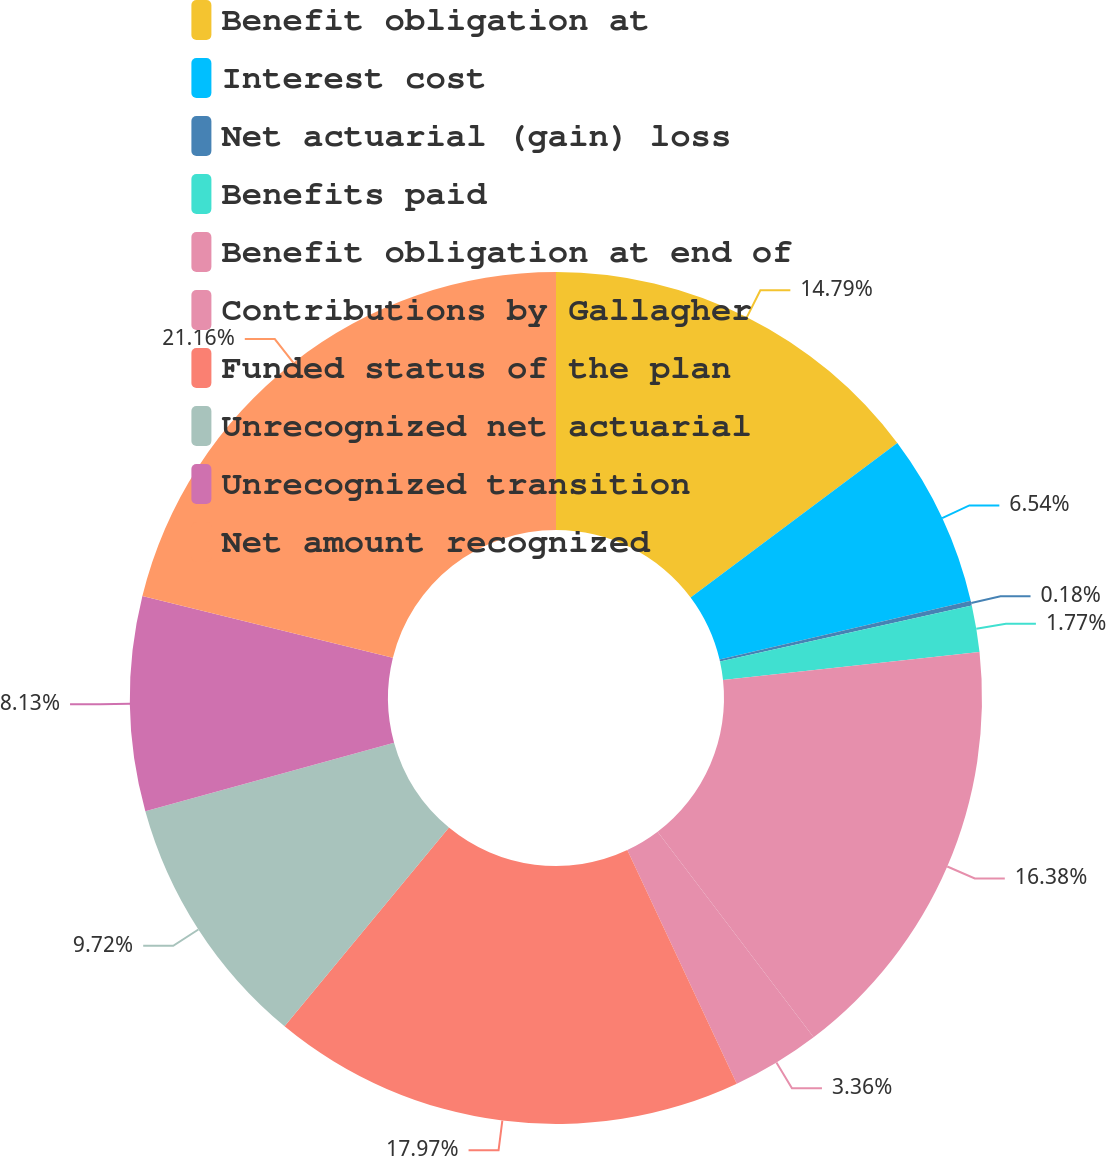Convert chart. <chart><loc_0><loc_0><loc_500><loc_500><pie_chart><fcel>Benefit obligation at<fcel>Interest cost<fcel>Net actuarial (gain) loss<fcel>Benefits paid<fcel>Benefit obligation at end of<fcel>Contributions by Gallagher<fcel>Funded status of the plan<fcel>Unrecognized net actuarial<fcel>Unrecognized transition<fcel>Net amount recognized<nl><fcel>14.79%<fcel>6.54%<fcel>0.18%<fcel>1.77%<fcel>16.38%<fcel>3.36%<fcel>17.97%<fcel>9.72%<fcel>8.13%<fcel>21.15%<nl></chart> 